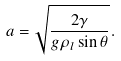Convert formula to latex. <formula><loc_0><loc_0><loc_500><loc_500>a = \sqrt { \frac { 2 \gamma } { g \rho _ { l } \sin \theta } } .</formula> 